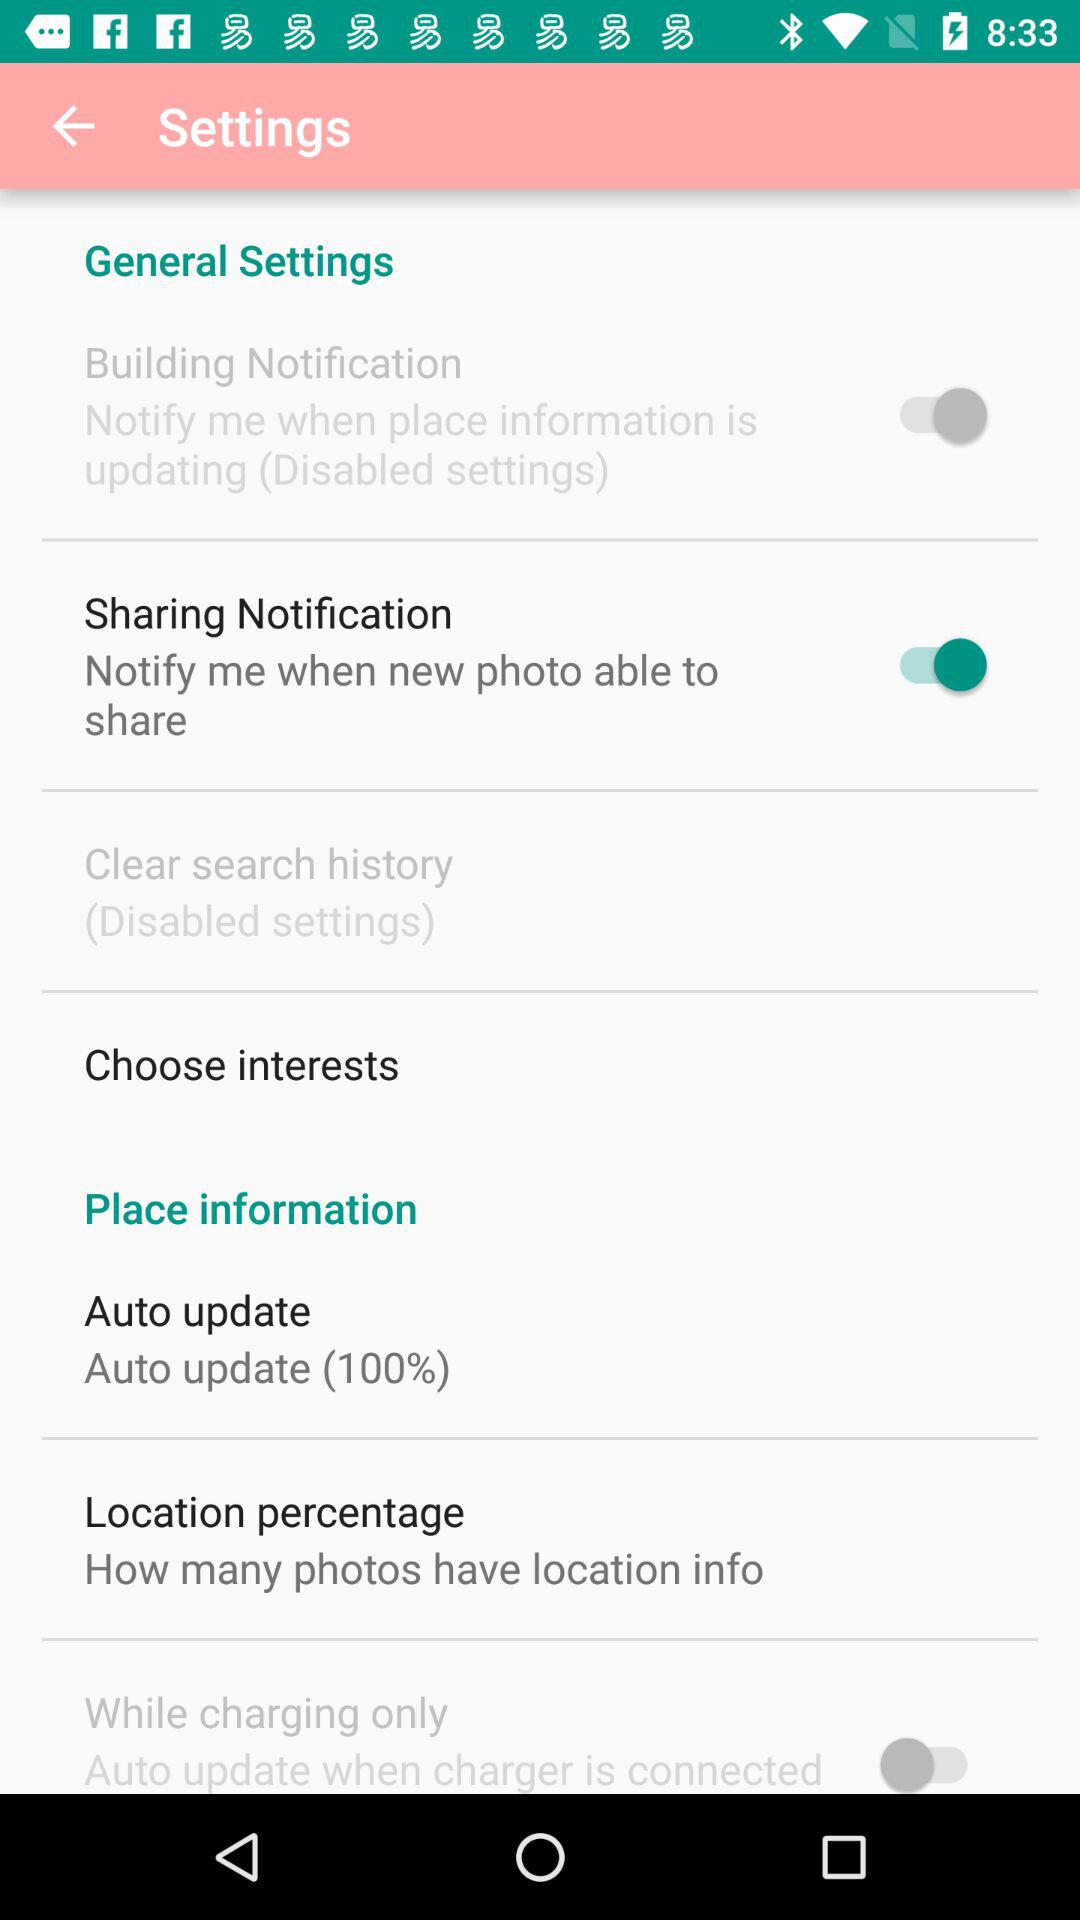How many of these settings are disabled?
Answer the question using a single word or phrase. 2 